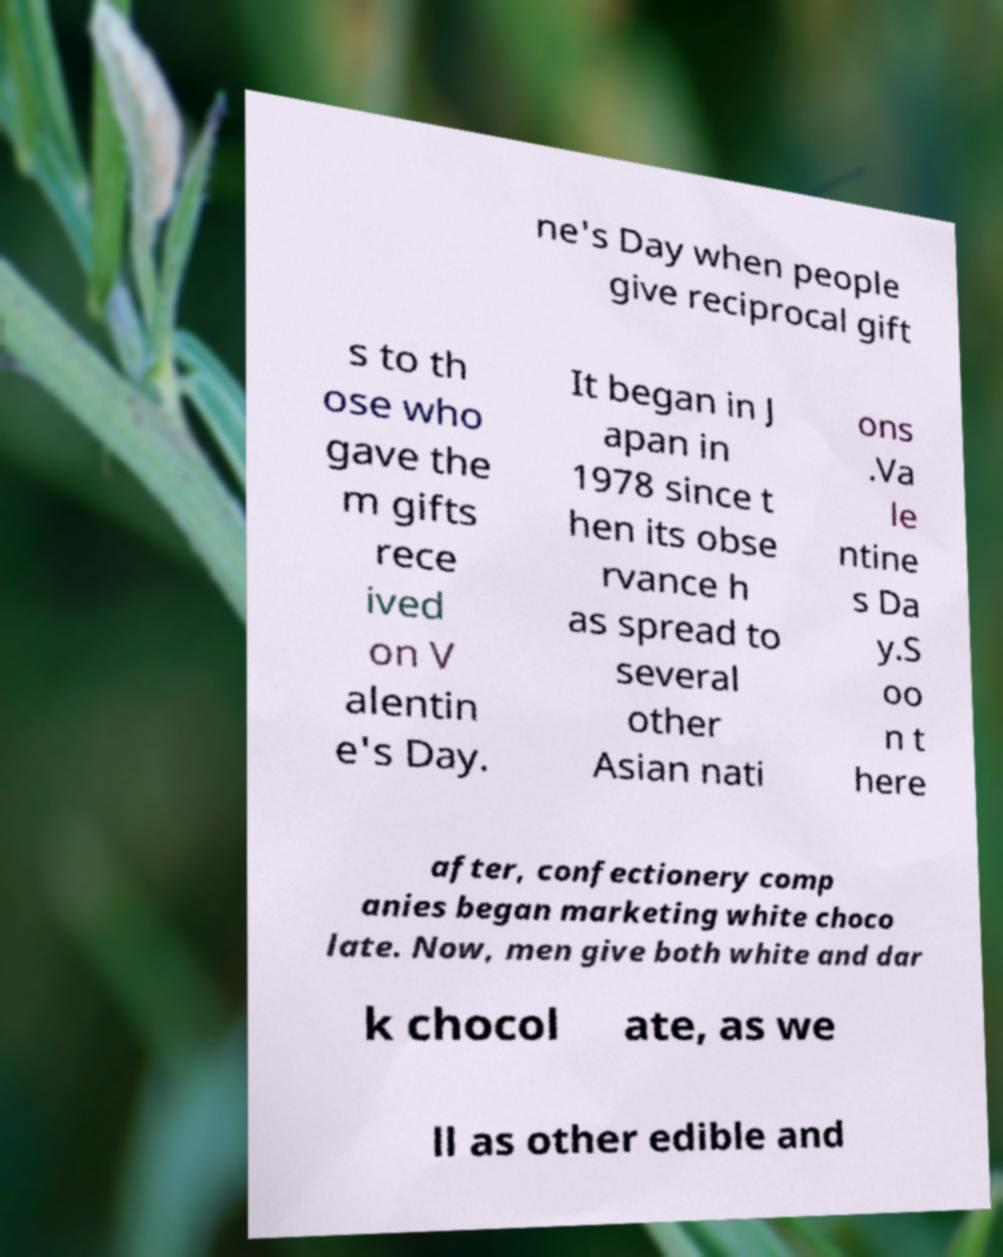For documentation purposes, I need the text within this image transcribed. Could you provide that? ne's Day when people give reciprocal gift s to th ose who gave the m gifts rece ived on V alentin e's Day. It began in J apan in 1978 since t hen its obse rvance h as spread to several other Asian nati ons .Va le ntine s Da y.S oo n t here after, confectionery comp anies began marketing white choco late. Now, men give both white and dar k chocol ate, as we ll as other edible and 